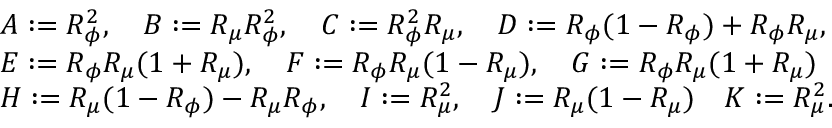Convert formula to latex. <formula><loc_0><loc_0><loc_500><loc_500>\begin{array} { r l } & { A \colon = R _ { \phi } ^ { 2 } , \quad B \colon = R _ { \mu } R _ { \phi } ^ { 2 } , \quad C \colon = R _ { \phi } ^ { 2 } R _ { \mu } , \quad D \colon = R _ { \phi } ( 1 - R _ { \phi } ) + R _ { \phi } R _ { \mu } , } \\ & { E \colon = R _ { \phi } R _ { \mu } ( 1 + R _ { \mu } ) , \quad F \colon = R _ { \phi } R _ { \mu } ( 1 - R _ { \mu } ) , \quad G \colon = R _ { \phi } R _ { \mu } ( 1 + R _ { \mu } ) } \\ & { H \colon = R _ { \mu } ( 1 - R _ { \phi } ) - R _ { \mu } R _ { \phi } , \quad I \colon = R _ { \mu } ^ { 2 } , \quad J \colon = R _ { \mu } ( 1 - R _ { \mu } ) \quad K \colon = R _ { \mu } ^ { 2 } . } \end{array}</formula> 